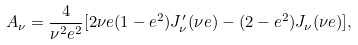Convert formula to latex. <formula><loc_0><loc_0><loc_500><loc_500>A _ { \nu } = \frac { 4 } { \nu ^ { 2 } e ^ { 2 } } [ 2 \nu e ( 1 - e ^ { 2 } ) J ^ { \prime } _ { \nu } ( \nu e ) - ( 2 - e ^ { 2 } ) J _ { \nu } ( \nu e ) ] ,</formula> 